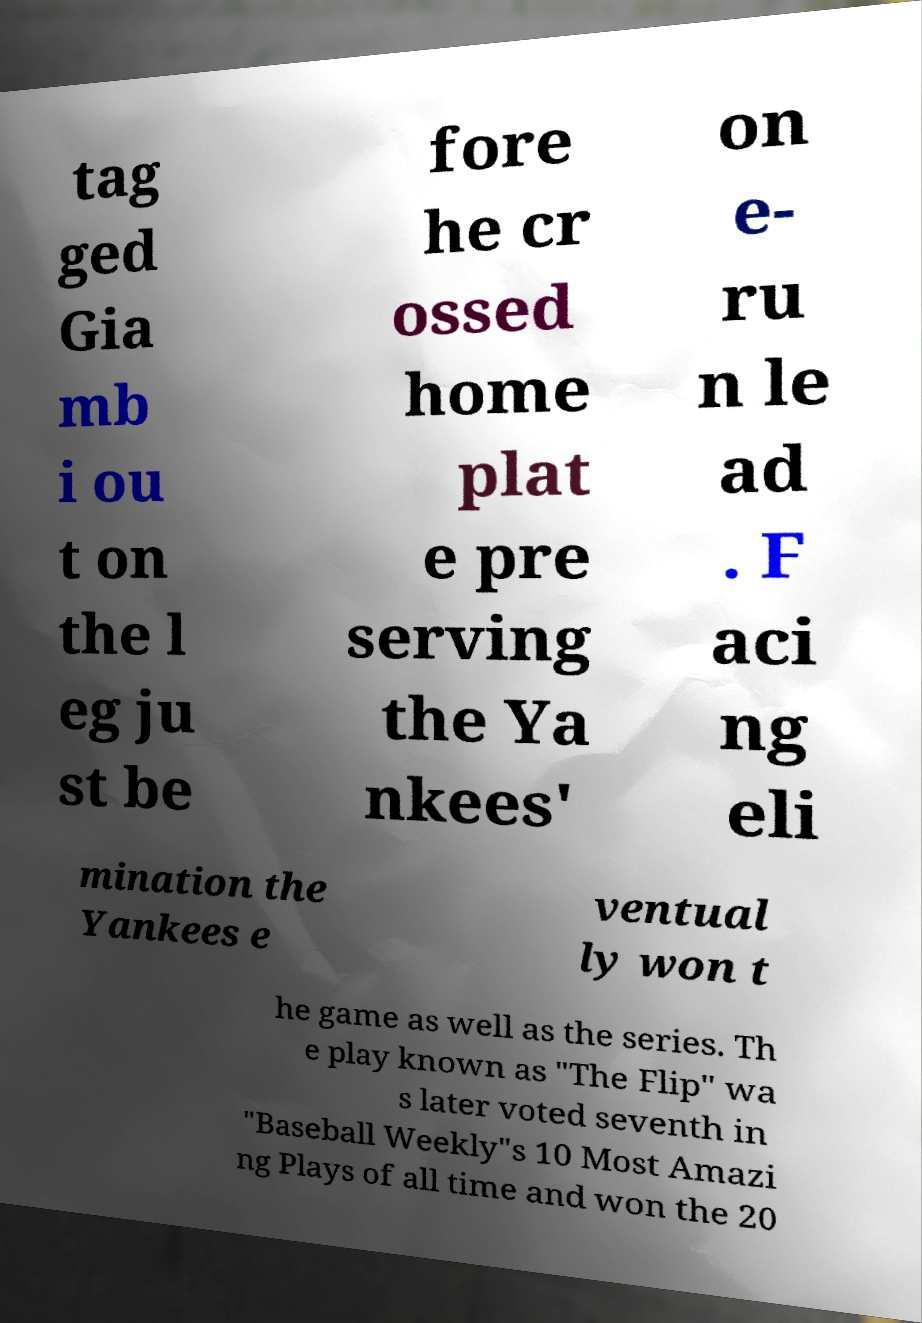Can you accurately transcribe the text from the provided image for me? tag ged Gia mb i ou t on the l eg ju st be fore he cr ossed home plat e pre serving the Ya nkees' on e- ru n le ad . F aci ng eli mination the Yankees e ventual ly won t he game as well as the series. Th e play known as "The Flip" wa s later voted seventh in "Baseball Weekly"s 10 Most Amazi ng Plays of all time and won the 20 